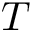Convert formula to latex. <formula><loc_0><loc_0><loc_500><loc_500>T</formula> 